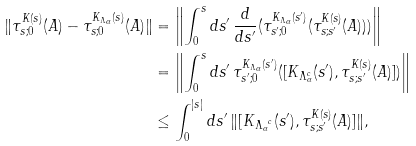<formula> <loc_0><loc_0><loc_500><loc_500>\| \tau _ { s ; 0 } ^ { K ( s ) } ( A ) - \tau _ { s ; 0 } ^ { K _ { \Lambda _ { \alpha } } ( s ) } ( A ) \| & = \left \| \int _ { 0 } ^ { s } d s ^ { \prime } \, \frac { d } { d s ^ { \prime } } ( \tau _ { s ^ { \prime } ; 0 } ^ { K _ { \Lambda _ { \alpha } } ( s ^ { \prime } ) } ( \tau _ { s ; s ^ { \prime } } ^ { K ( s ) } ( A ) ) ) \right \| \\ & = \left \| \int _ { 0 } ^ { s } d s ^ { \prime } \, \tau _ { s ^ { \prime } ; 0 } ^ { K _ { \Lambda _ { \alpha } } ( s ^ { \prime } ) } ( [ K _ { \Lambda _ { \alpha } ^ { c } } ( s ^ { \prime } ) , \tau _ { s ; s ^ { \prime } } ^ { K ( s ) } ( A ) ] ) \right \| \\ & \leq \int _ { 0 } ^ { | s | } d s ^ { \prime } \, \| [ K _ { { \Lambda _ { \alpha } } ^ { c } } ( s ^ { \prime } ) , \tau _ { s ; s ^ { \prime } } ^ { K ( s ) } ( A ) ] \| ,</formula> 